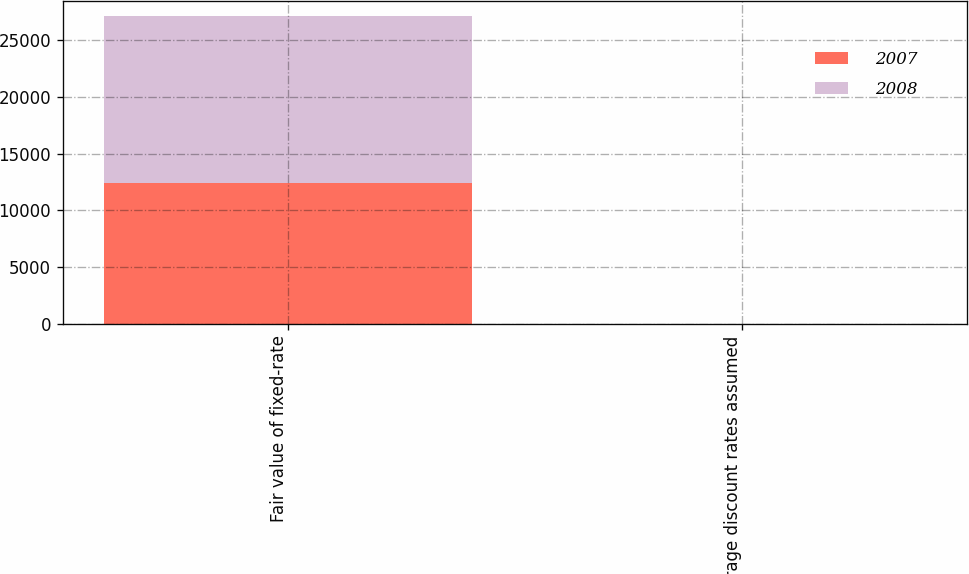Convert chart. <chart><loc_0><loc_0><loc_500><loc_500><stacked_bar_chart><ecel><fcel>Fair value of fixed-rate<fcel>Average discount rates assumed<nl><fcel>2007<fcel>12385<fcel>6.33<nl><fcel>2008<fcel>14742<fcel>5.23<nl></chart> 